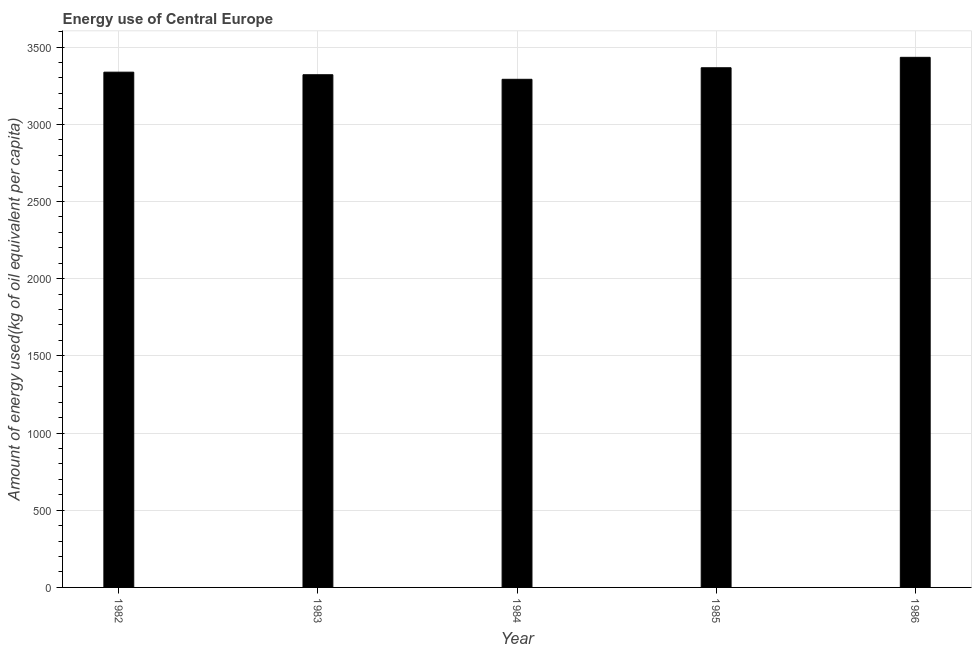Does the graph contain grids?
Provide a short and direct response. Yes. What is the title of the graph?
Your answer should be very brief. Energy use of Central Europe. What is the label or title of the X-axis?
Provide a succinct answer. Year. What is the label or title of the Y-axis?
Give a very brief answer. Amount of energy used(kg of oil equivalent per capita). What is the amount of energy used in 1983?
Provide a short and direct response. 3320.97. Across all years, what is the maximum amount of energy used?
Your answer should be compact. 3433.73. Across all years, what is the minimum amount of energy used?
Your response must be concise. 3291.37. In which year was the amount of energy used minimum?
Keep it short and to the point. 1984. What is the sum of the amount of energy used?
Your answer should be compact. 1.67e+04. What is the difference between the amount of energy used in 1983 and 1984?
Your response must be concise. 29.59. What is the average amount of energy used per year?
Offer a terse response. 3349.96. What is the median amount of energy used?
Provide a succinct answer. 3337.53. What is the ratio of the amount of energy used in 1982 to that in 1984?
Offer a very short reply. 1.01. Is the amount of energy used in 1984 less than that in 1986?
Make the answer very short. Yes. What is the difference between the highest and the second highest amount of energy used?
Keep it short and to the point. 67.52. What is the difference between the highest and the lowest amount of energy used?
Ensure brevity in your answer.  142.36. In how many years, is the amount of energy used greater than the average amount of energy used taken over all years?
Give a very brief answer. 2. How many bars are there?
Ensure brevity in your answer.  5. How many years are there in the graph?
Keep it short and to the point. 5. Are the values on the major ticks of Y-axis written in scientific E-notation?
Your answer should be very brief. No. What is the Amount of energy used(kg of oil equivalent per capita) in 1982?
Make the answer very short. 3337.53. What is the Amount of energy used(kg of oil equivalent per capita) of 1983?
Offer a very short reply. 3320.97. What is the Amount of energy used(kg of oil equivalent per capita) of 1984?
Offer a terse response. 3291.37. What is the Amount of energy used(kg of oil equivalent per capita) in 1985?
Provide a succinct answer. 3366.21. What is the Amount of energy used(kg of oil equivalent per capita) of 1986?
Make the answer very short. 3433.73. What is the difference between the Amount of energy used(kg of oil equivalent per capita) in 1982 and 1983?
Make the answer very short. 16.56. What is the difference between the Amount of energy used(kg of oil equivalent per capita) in 1982 and 1984?
Your answer should be very brief. 46.15. What is the difference between the Amount of energy used(kg of oil equivalent per capita) in 1982 and 1985?
Your response must be concise. -28.69. What is the difference between the Amount of energy used(kg of oil equivalent per capita) in 1982 and 1986?
Give a very brief answer. -96.2. What is the difference between the Amount of energy used(kg of oil equivalent per capita) in 1983 and 1984?
Your answer should be very brief. 29.59. What is the difference between the Amount of energy used(kg of oil equivalent per capita) in 1983 and 1985?
Provide a succinct answer. -45.25. What is the difference between the Amount of energy used(kg of oil equivalent per capita) in 1983 and 1986?
Keep it short and to the point. -112.76. What is the difference between the Amount of energy used(kg of oil equivalent per capita) in 1984 and 1985?
Keep it short and to the point. -74.84. What is the difference between the Amount of energy used(kg of oil equivalent per capita) in 1984 and 1986?
Give a very brief answer. -142.36. What is the difference between the Amount of energy used(kg of oil equivalent per capita) in 1985 and 1986?
Keep it short and to the point. -67.52. What is the ratio of the Amount of energy used(kg of oil equivalent per capita) in 1982 to that in 1983?
Provide a succinct answer. 1. What is the ratio of the Amount of energy used(kg of oil equivalent per capita) in 1982 to that in 1984?
Your answer should be compact. 1.01. What is the ratio of the Amount of energy used(kg of oil equivalent per capita) in 1982 to that in 1985?
Offer a terse response. 0.99. What is the ratio of the Amount of energy used(kg of oil equivalent per capita) in 1983 to that in 1984?
Give a very brief answer. 1.01. What is the ratio of the Amount of energy used(kg of oil equivalent per capita) in 1983 to that in 1986?
Your response must be concise. 0.97. What is the ratio of the Amount of energy used(kg of oil equivalent per capita) in 1985 to that in 1986?
Provide a succinct answer. 0.98. 